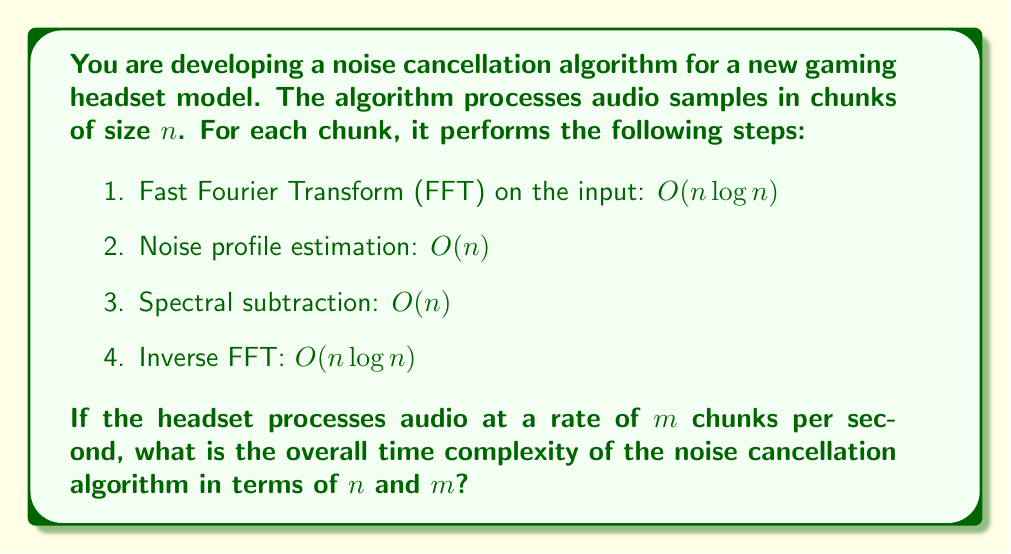Can you answer this question? To analyze the time complexity of this noise cancellation algorithm, we need to:

1. Determine the complexity of processing a single chunk:
   - FFT: $O(n \log n)$
   - Noise profile estimation: $O(n)$
   - Spectral subtraction: $O(n)$
   - Inverse FFT: $O(n \log n)$

   The total complexity for one chunk is:
   $O(n \log n) + O(n) + O(n) + O(n \log n) = O(2n \log n + 2n) = O(n \log n)$

2. Consider the number of chunks processed per second:
   The algorithm processes $m$ chunks per second.

3. Calculate the overall complexity:
   For $m$ chunks, the complexity becomes:
   $O(m \cdot n \log n)$

This represents the number of operations performed per second by the noise cancellation algorithm.

Note: In real-time audio processing, $n$ is typically fixed (e.g., 1024 or 2048 samples per chunk), and $m$ is determined by the audio sample rate and chunk size. However, for algorithm analysis purposes, we keep both variables to show how the complexity scales with both chunk size and processing rate.
Answer: $O(m \cdot n \log n)$ 